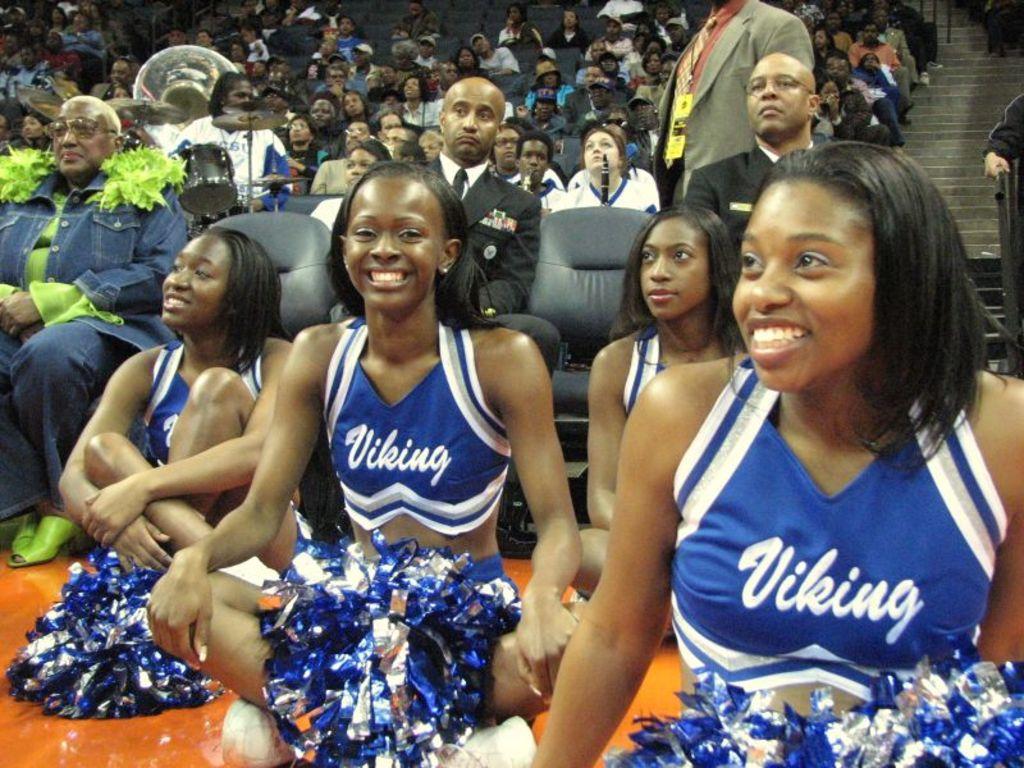Which team do these cheerleaders root for?
Your response must be concise. Viking. 